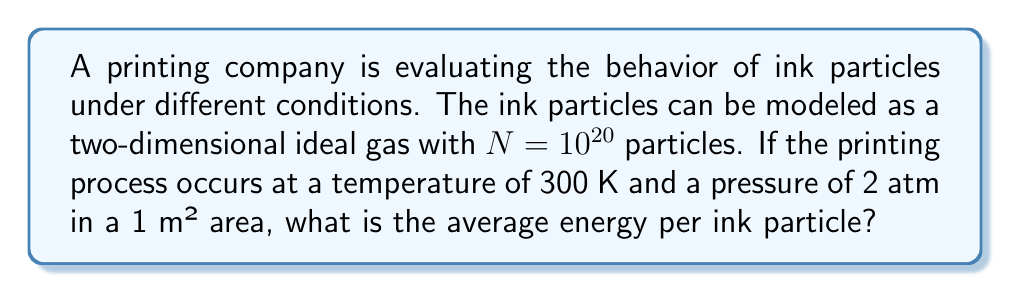Provide a solution to this math problem. To solve this problem, we'll use concepts from statistical mechanics:

1) For an ideal gas in two dimensions, the average energy per particle is given by the equipartition theorem:

   $$\langle E \rangle = kT$$

   where $k$ is the Boltzmann constant and $T$ is the temperature in Kelvin.

2) We're given:
   - Temperature $T = 300$ K
   - Boltzmann constant $k = 1.38 \times 10^{-23}$ J/K

3) Plug these values into the equation:

   $$\langle E \rangle = (1.38 \times 10^{-23} \text{ J/K})(300 \text{ K})$$

4) Calculate:

   $$\langle E \rangle = 4.14 \times 10^{-21} \text{ J}$$

5) Convert to electron volts (eV) for a more convenient unit:
   
   $$\langle E \rangle = (4.14 \times 10^{-21} \text{ J}) \cdot \frac{1 \text{ eV}}{1.602 \times 10^{-19} \text{ J}} = 0.0258 \text{ eV}$$

Note: The pressure and area information weren't needed for this calculation, as the average energy per particle in an ideal gas depends only on temperature.
Answer: 0.0258 eV 